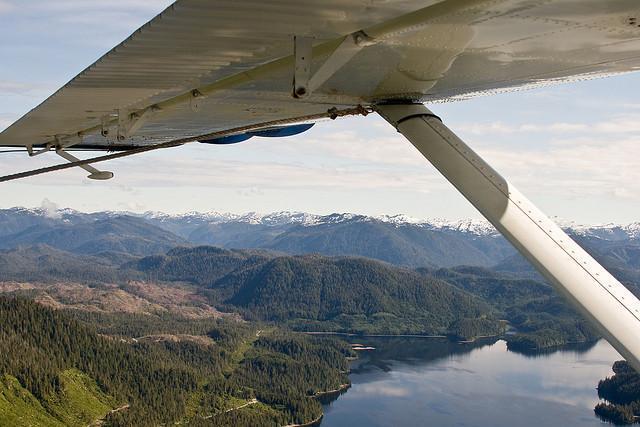How many trains are seen?
Give a very brief answer. 0. 